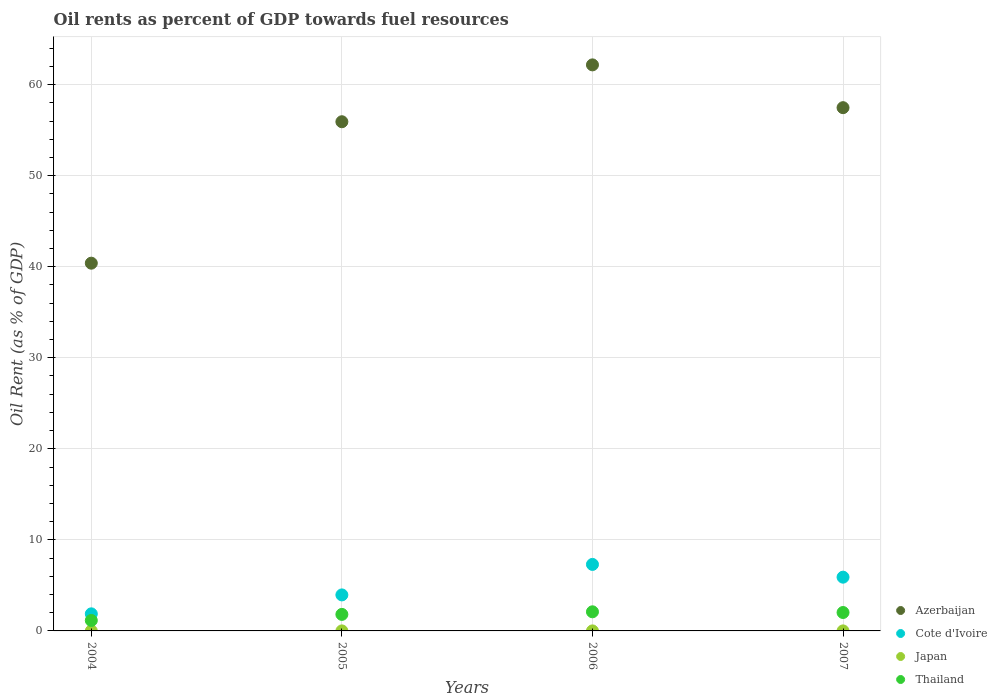How many different coloured dotlines are there?
Give a very brief answer. 4. What is the oil rent in Japan in 2005?
Your answer should be very brief. 0. Across all years, what is the maximum oil rent in Thailand?
Your answer should be compact. 2.1. Across all years, what is the minimum oil rent in Cote d'Ivoire?
Offer a terse response. 1.88. In which year was the oil rent in Thailand minimum?
Give a very brief answer. 2004. What is the total oil rent in Azerbaijan in the graph?
Offer a very short reply. 215.94. What is the difference between the oil rent in Thailand in 2004 and that in 2007?
Offer a very short reply. -0.87. What is the difference between the oil rent in Thailand in 2004 and the oil rent in Japan in 2005?
Offer a terse response. 1.15. What is the average oil rent in Cote d'Ivoire per year?
Provide a succinct answer. 4.76. In the year 2006, what is the difference between the oil rent in Azerbaijan and oil rent in Thailand?
Give a very brief answer. 60.07. What is the ratio of the oil rent in Thailand in 2005 to that in 2007?
Keep it short and to the point. 0.9. Is the oil rent in Azerbaijan in 2006 less than that in 2007?
Offer a very short reply. No. Is the difference between the oil rent in Azerbaijan in 2005 and 2007 greater than the difference between the oil rent in Thailand in 2005 and 2007?
Provide a succinct answer. No. What is the difference between the highest and the second highest oil rent in Japan?
Provide a short and direct response. 0. What is the difference between the highest and the lowest oil rent in Japan?
Your answer should be compact. 0. Is it the case that in every year, the sum of the oil rent in Cote d'Ivoire and oil rent in Thailand  is greater than the oil rent in Japan?
Offer a very short reply. Yes. Does the oil rent in Cote d'Ivoire monotonically increase over the years?
Make the answer very short. No. Is the oil rent in Thailand strictly greater than the oil rent in Japan over the years?
Keep it short and to the point. Yes. Does the graph contain grids?
Your answer should be compact. Yes. How many legend labels are there?
Your answer should be compact. 4. How are the legend labels stacked?
Provide a short and direct response. Vertical. What is the title of the graph?
Offer a very short reply. Oil rents as percent of GDP towards fuel resources. What is the label or title of the X-axis?
Your answer should be very brief. Years. What is the label or title of the Y-axis?
Your response must be concise. Oil Rent (as % of GDP). What is the Oil Rent (as % of GDP) in Azerbaijan in 2004?
Provide a short and direct response. 40.39. What is the Oil Rent (as % of GDP) in Cote d'Ivoire in 2004?
Your response must be concise. 1.88. What is the Oil Rent (as % of GDP) of Japan in 2004?
Ensure brevity in your answer.  0. What is the Oil Rent (as % of GDP) in Thailand in 2004?
Your answer should be compact. 1.15. What is the Oil Rent (as % of GDP) in Azerbaijan in 2005?
Provide a succinct answer. 55.92. What is the Oil Rent (as % of GDP) in Cote d'Ivoire in 2005?
Offer a very short reply. 3.96. What is the Oil Rent (as % of GDP) in Japan in 2005?
Ensure brevity in your answer.  0. What is the Oil Rent (as % of GDP) in Thailand in 2005?
Provide a succinct answer. 1.81. What is the Oil Rent (as % of GDP) of Azerbaijan in 2006?
Provide a short and direct response. 62.17. What is the Oil Rent (as % of GDP) in Cote d'Ivoire in 2006?
Offer a very short reply. 7.3. What is the Oil Rent (as % of GDP) of Japan in 2006?
Offer a terse response. 0. What is the Oil Rent (as % of GDP) in Thailand in 2006?
Make the answer very short. 2.1. What is the Oil Rent (as % of GDP) in Azerbaijan in 2007?
Offer a terse response. 57.47. What is the Oil Rent (as % of GDP) of Cote d'Ivoire in 2007?
Your answer should be compact. 5.9. What is the Oil Rent (as % of GDP) in Japan in 2007?
Offer a very short reply. 0. What is the Oil Rent (as % of GDP) of Thailand in 2007?
Make the answer very short. 2.02. Across all years, what is the maximum Oil Rent (as % of GDP) of Azerbaijan?
Provide a succinct answer. 62.17. Across all years, what is the maximum Oil Rent (as % of GDP) of Cote d'Ivoire?
Your response must be concise. 7.3. Across all years, what is the maximum Oil Rent (as % of GDP) of Japan?
Offer a very short reply. 0. Across all years, what is the maximum Oil Rent (as % of GDP) of Thailand?
Your answer should be very brief. 2.1. Across all years, what is the minimum Oil Rent (as % of GDP) in Azerbaijan?
Provide a short and direct response. 40.39. Across all years, what is the minimum Oil Rent (as % of GDP) of Cote d'Ivoire?
Keep it short and to the point. 1.88. Across all years, what is the minimum Oil Rent (as % of GDP) in Japan?
Your answer should be very brief. 0. Across all years, what is the minimum Oil Rent (as % of GDP) in Thailand?
Ensure brevity in your answer.  1.15. What is the total Oil Rent (as % of GDP) in Azerbaijan in the graph?
Provide a short and direct response. 215.94. What is the total Oil Rent (as % of GDP) in Cote d'Ivoire in the graph?
Make the answer very short. 19.04. What is the total Oil Rent (as % of GDP) of Japan in the graph?
Make the answer very short. 0.01. What is the total Oil Rent (as % of GDP) of Thailand in the graph?
Your answer should be compact. 7.09. What is the difference between the Oil Rent (as % of GDP) of Azerbaijan in 2004 and that in 2005?
Offer a very short reply. -15.53. What is the difference between the Oil Rent (as % of GDP) in Cote d'Ivoire in 2004 and that in 2005?
Ensure brevity in your answer.  -2.08. What is the difference between the Oil Rent (as % of GDP) of Japan in 2004 and that in 2005?
Your response must be concise. -0. What is the difference between the Oil Rent (as % of GDP) in Thailand in 2004 and that in 2005?
Your answer should be very brief. -0.67. What is the difference between the Oil Rent (as % of GDP) of Azerbaijan in 2004 and that in 2006?
Ensure brevity in your answer.  -21.78. What is the difference between the Oil Rent (as % of GDP) in Cote d'Ivoire in 2004 and that in 2006?
Keep it short and to the point. -5.43. What is the difference between the Oil Rent (as % of GDP) in Japan in 2004 and that in 2006?
Provide a succinct answer. -0. What is the difference between the Oil Rent (as % of GDP) of Thailand in 2004 and that in 2006?
Keep it short and to the point. -0.95. What is the difference between the Oil Rent (as % of GDP) of Azerbaijan in 2004 and that in 2007?
Provide a succinct answer. -17.08. What is the difference between the Oil Rent (as % of GDP) of Cote d'Ivoire in 2004 and that in 2007?
Your response must be concise. -4.03. What is the difference between the Oil Rent (as % of GDP) of Japan in 2004 and that in 2007?
Offer a very short reply. -0. What is the difference between the Oil Rent (as % of GDP) of Thailand in 2004 and that in 2007?
Make the answer very short. -0.87. What is the difference between the Oil Rent (as % of GDP) of Azerbaijan in 2005 and that in 2006?
Give a very brief answer. -6.24. What is the difference between the Oil Rent (as % of GDP) of Cote d'Ivoire in 2005 and that in 2006?
Provide a short and direct response. -3.35. What is the difference between the Oil Rent (as % of GDP) of Japan in 2005 and that in 2006?
Provide a short and direct response. -0. What is the difference between the Oil Rent (as % of GDP) in Thailand in 2005 and that in 2006?
Keep it short and to the point. -0.29. What is the difference between the Oil Rent (as % of GDP) of Azerbaijan in 2005 and that in 2007?
Give a very brief answer. -1.54. What is the difference between the Oil Rent (as % of GDP) in Cote d'Ivoire in 2005 and that in 2007?
Offer a very short reply. -1.95. What is the difference between the Oil Rent (as % of GDP) in Japan in 2005 and that in 2007?
Keep it short and to the point. -0. What is the difference between the Oil Rent (as % of GDP) of Thailand in 2005 and that in 2007?
Offer a very short reply. -0.21. What is the difference between the Oil Rent (as % of GDP) of Azerbaijan in 2006 and that in 2007?
Your answer should be very brief. 4.7. What is the difference between the Oil Rent (as % of GDP) in Cote d'Ivoire in 2006 and that in 2007?
Make the answer very short. 1.4. What is the difference between the Oil Rent (as % of GDP) in Japan in 2006 and that in 2007?
Your response must be concise. -0. What is the difference between the Oil Rent (as % of GDP) in Thailand in 2006 and that in 2007?
Provide a succinct answer. 0.08. What is the difference between the Oil Rent (as % of GDP) in Azerbaijan in 2004 and the Oil Rent (as % of GDP) in Cote d'Ivoire in 2005?
Make the answer very short. 36.43. What is the difference between the Oil Rent (as % of GDP) of Azerbaijan in 2004 and the Oil Rent (as % of GDP) of Japan in 2005?
Provide a short and direct response. 40.38. What is the difference between the Oil Rent (as % of GDP) of Azerbaijan in 2004 and the Oil Rent (as % of GDP) of Thailand in 2005?
Provide a short and direct response. 38.57. What is the difference between the Oil Rent (as % of GDP) of Cote d'Ivoire in 2004 and the Oil Rent (as % of GDP) of Japan in 2005?
Offer a terse response. 1.87. What is the difference between the Oil Rent (as % of GDP) in Cote d'Ivoire in 2004 and the Oil Rent (as % of GDP) in Thailand in 2005?
Offer a very short reply. 0.06. What is the difference between the Oil Rent (as % of GDP) in Japan in 2004 and the Oil Rent (as % of GDP) in Thailand in 2005?
Your response must be concise. -1.81. What is the difference between the Oil Rent (as % of GDP) in Azerbaijan in 2004 and the Oil Rent (as % of GDP) in Cote d'Ivoire in 2006?
Provide a short and direct response. 33.08. What is the difference between the Oil Rent (as % of GDP) in Azerbaijan in 2004 and the Oil Rent (as % of GDP) in Japan in 2006?
Your response must be concise. 40.38. What is the difference between the Oil Rent (as % of GDP) of Azerbaijan in 2004 and the Oil Rent (as % of GDP) of Thailand in 2006?
Keep it short and to the point. 38.29. What is the difference between the Oil Rent (as % of GDP) of Cote d'Ivoire in 2004 and the Oil Rent (as % of GDP) of Japan in 2006?
Your response must be concise. 1.87. What is the difference between the Oil Rent (as % of GDP) in Cote d'Ivoire in 2004 and the Oil Rent (as % of GDP) in Thailand in 2006?
Offer a terse response. -0.22. What is the difference between the Oil Rent (as % of GDP) in Japan in 2004 and the Oil Rent (as % of GDP) in Thailand in 2006?
Give a very brief answer. -2.1. What is the difference between the Oil Rent (as % of GDP) in Azerbaijan in 2004 and the Oil Rent (as % of GDP) in Cote d'Ivoire in 2007?
Offer a very short reply. 34.48. What is the difference between the Oil Rent (as % of GDP) in Azerbaijan in 2004 and the Oil Rent (as % of GDP) in Japan in 2007?
Provide a succinct answer. 40.38. What is the difference between the Oil Rent (as % of GDP) of Azerbaijan in 2004 and the Oil Rent (as % of GDP) of Thailand in 2007?
Provide a short and direct response. 38.36. What is the difference between the Oil Rent (as % of GDP) of Cote d'Ivoire in 2004 and the Oil Rent (as % of GDP) of Japan in 2007?
Make the answer very short. 1.87. What is the difference between the Oil Rent (as % of GDP) in Cote d'Ivoire in 2004 and the Oil Rent (as % of GDP) in Thailand in 2007?
Offer a terse response. -0.15. What is the difference between the Oil Rent (as % of GDP) of Japan in 2004 and the Oil Rent (as % of GDP) of Thailand in 2007?
Your answer should be compact. -2.02. What is the difference between the Oil Rent (as % of GDP) in Azerbaijan in 2005 and the Oil Rent (as % of GDP) in Cote d'Ivoire in 2006?
Offer a terse response. 48.62. What is the difference between the Oil Rent (as % of GDP) of Azerbaijan in 2005 and the Oil Rent (as % of GDP) of Japan in 2006?
Offer a very short reply. 55.92. What is the difference between the Oil Rent (as % of GDP) of Azerbaijan in 2005 and the Oil Rent (as % of GDP) of Thailand in 2006?
Provide a succinct answer. 53.82. What is the difference between the Oil Rent (as % of GDP) in Cote d'Ivoire in 2005 and the Oil Rent (as % of GDP) in Japan in 2006?
Keep it short and to the point. 3.95. What is the difference between the Oil Rent (as % of GDP) in Cote d'Ivoire in 2005 and the Oil Rent (as % of GDP) in Thailand in 2006?
Provide a succinct answer. 1.86. What is the difference between the Oil Rent (as % of GDP) in Japan in 2005 and the Oil Rent (as % of GDP) in Thailand in 2006?
Keep it short and to the point. -2.1. What is the difference between the Oil Rent (as % of GDP) of Azerbaijan in 2005 and the Oil Rent (as % of GDP) of Cote d'Ivoire in 2007?
Your answer should be compact. 50.02. What is the difference between the Oil Rent (as % of GDP) in Azerbaijan in 2005 and the Oil Rent (as % of GDP) in Japan in 2007?
Your answer should be very brief. 55.92. What is the difference between the Oil Rent (as % of GDP) of Azerbaijan in 2005 and the Oil Rent (as % of GDP) of Thailand in 2007?
Offer a terse response. 53.9. What is the difference between the Oil Rent (as % of GDP) in Cote d'Ivoire in 2005 and the Oil Rent (as % of GDP) in Japan in 2007?
Your answer should be compact. 3.95. What is the difference between the Oil Rent (as % of GDP) of Cote d'Ivoire in 2005 and the Oil Rent (as % of GDP) of Thailand in 2007?
Keep it short and to the point. 1.93. What is the difference between the Oil Rent (as % of GDP) of Japan in 2005 and the Oil Rent (as % of GDP) of Thailand in 2007?
Your response must be concise. -2.02. What is the difference between the Oil Rent (as % of GDP) in Azerbaijan in 2006 and the Oil Rent (as % of GDP) in Cote d'Ivoire in 2007?
Make the answer very short. 56.26. What is the difference between the Oil Rent (as % of GDP) of Azerbaijan in 2006 and the Oil Rent (as % of GDP) of Japan in 2007?
Provide a short and direct response. 62.16. What is the difference between the Oil Rent (as % of GDP) in Azerbaijan in 2006 and the Oil Rent (as % of GDP) in Thailand in 2007?
Provide a short and direct response. 60.14. What is the difference between the Oil Rent (as % of GDP) of Cote d'Ivoire in 2006 and the Oil Rent (as % of GDP) of Japan in 2007?
Make the answer very short. 7.3. What is the difference between the Oil Rent (as % of GDP) in Cote d'Ivoire in 2006 and the Oil Rent (as % of GDP) in Thailand in 2007?
Give a very brief answer. 5.28. What is the difference between the Oil Rent (as % of GDP) in Japan in 2006 and the Oil Rent (as % of GDP) in Thailand in 2007?
Offer a very short reply. -2.02. What is the average Oil Rent (as % of GDP) in Azerbaijan per year?
Ensure brevity in your answer.  53.98. What is the average Oil Rent (as % of GDP) in Cote d'Ivoire per year?
Your response must be concise. 4.76. What is the average Oil Rent (as % of GDP) in Japan per year?
Provide a short and direct response. 0. What is the average Oil Rent (as % of GDP) in Thailand per year?
Ensure brevity in your answer.  1.77. In the year 2004, what is the difference between the Oil Rent (as % of GDP) of Azerbaijan and Oil Rent (as % of GDP) of Cote d'Ivoire?
Your response must be concise. 38.51. In the year 2004, what is the difference between the Oil Rent (as % of GDP) in Azerbaijan and Oil Rent (as % of GDP) in Japan?
Ensure brevity in your answer.  40.38. In the year 2004, what is the difference between the Oil Rent (as % of GDP) in Azerbaijan and Oil Rent (as % of GDP) in Thailand?
Your answer should be compact. 39.24. In the year 2004, what is the difference between the Oil Rent (as % of GDP) in Cote d'Ivoire and Oil Rent (as % of GDP) in Japan?
Your answer should be very brief. 1.87. In the year 2004, what is the difference between the Oil Rent (as % of GDP) in Cote d'Ivoire and Oil Rent (as % of GDP) in Thailand?
Provide a succinct answer. 0.73. In the year 2004, what is the difference between the Oil Rent (as % of GDP) in Japan and Oil Rent (as % of GDP) in Thailand?
Your response must be concise. -1.15. In the year 2005, what is the difference between the Oil Rent (as % of GDP) of Azerbaijan and Oil Rent (as % of GDP) of Cote d'Ivoire?
Your answer should be very brief. 51.97. In the year 2005, what is the difference between the Oil Rent (as % of GDP) of Azerbaijan and Oil Rent (as % of GDP) of Japan?
Your answer should be compact. 55.92. In the year 2005, what is the difference between the Oil Rent (as % of GDP) in Azerbaijan and Oil Rent (as % of GDP) in Thailand?
Provide a succinct answer. 54.11. In the year 2005, what is the difference between the Oil Rent (as % of GDP) in Cote d'Ivoire and Oil Rent (as % of GDP) in Japan?
Offer a terse response. 3.95. In the year 2005, what is the difference between the Oil Rent (as % of GDP) of Cote d'Ivoire and Oil Rent (as % of GDP) of Thailand?
Keep it short and to the point. 2.14. In the year 2005, what is the difference between the Oil Rent (as % of GDP) in Japan and Oil Rent (as % of GDP) in Thailand?
Offer a terse response. -1.81. In the year 2006, what is the difference between the Oil Rent (as % of GDP) of Azerbaijan and Oil Rent (as % of GDP) of Cote d'Ivoire?
Make the answer very short. 54.86. In the year 2006, what is the difference between the Oil Rent (as % of GDP) of Azerbaijan and Oil Rent (as % of GDP) of Japan?
Your answer should be very brief. 62.16. In the year 2006, what is the difference between the Oil Rent (as % of GDP) in Azerbaijan and Oil Rent (as % of GDP) in Thailand?
Provide a short and direct response. 60.07. In the year 2006, what is the difference between the Oil Rent (as % of GDP) in Cote d'Ivoire and Oil Rent (as % of GDP) in Japan?
Offer a very short reply. 7.3. In the year 2006, what is the difference between the Oil Rent (as % of GDP) in Cote d'Ivoire and Oil Rent (as % of GDP) in Thailand?
Make the answer very short. 5.2. In the year 2006, what is the difference between the Oil Rent (as % of GDP) in Japan and Oil Rent (as % of GDP) in Thailand?
Provide a short and direct response. -2.1. In the year 2007, what is the difference between the Oil Rent (as % of GDP) in Azerbaijan and Oil Rent (as % of GDP) in Cote d'Ivoire?
Your response must be concise. 51.56. In the year 2007, what is the difference between the Oil Rent (as % of GDP) of Azerbaijan and Oil Rent (as % of GDP) of Japan?
Keep it short and to the point. 57.46. In the year 2007, what is the difference between the Oil Rent (as % of GDP) of Azerbaijan and Oil Rent (as % of GDP) of Thailand?
Make the answer very short. 55.44. In the year 2007, what is the difference between the Oil Rent (as % of GDP) of Cote d'Ivoire and Oil Rent (as % of GDP) of Japan?
Offer a very short reply. 5.9. In the year 2007, what is the difference between the Oil Rent (as % of GDP) of Cote d'Ivoire and Oil Rent (as % of GDP) of Thailand?
Your answer should be very brief. 3.88. In the year 2007, what is the difference between the Oil Rent (as % of GDP) of Japan and Oil Rent (as % of GDP) of Thailand?
Give a very brief answer. -2.02. What is the ratio of the Oil Rent (as % of GDP) of Azerbaijan in 2004 to that in 2005?
Provide a succinct answer. 0.72. What is the ratio of the Oil Rent (as % of GDP) in Cote d'Ivoire in 2004 to that in 2005?
Your answer should be compact. 0.47. What is the ratio of the Oil Rent (as % of GDP) in Japan in 2004 to that in 2005?
Give a very brief answer. 0.62. What is the ratio of the Oil Rent (as % of GDP) in Thailand in 2004 to that in 2005?
Your response must be concise. 0.63. What is the ratio of the Oil Rent (as % of GDP) in Azerbaijan in 2004 to that in 2006?
Offer a terse response. 0.65. What is the ratio of the Oil Rent (as % of GDP) in Cote d'Ivoire in 2004 to that in 2006?
Ensure brevity in your answer.  0.26. What is the ratio of the Oil Rent (as % of GDP) in Japan in 2004 to that in 2006?
Ensure brevity in your answer.  0.56. What is the ratio of the Oil Rent (as % of GDP) of Thailand in 2004 to that in 2006?
Your response must be concise. 0.55. What is the ratio of the Oil Rent (as % of GDP) in Azerbaijan in 2004 to that in 2007?
Provide a succinct answer. 0.7. What is the ratio of the Oil Rent (as % of GDP) in Cote d'Ivoire in 2004 to that in 2007?
Ensure brevity in your answer.  0.32. What is the ratio of the Oil Rent (as % of GDP) of Japan in 2004 to that in 2007?
Make the answer very short. 0.49. What is the ratio of the Oil Rent (as % of GDP) of Thailand in 2004 to that in 2007?
Give a very brief answer. 0.57. What is the ratio of the Oil Rent (as % of GDP) in Azerbaijan in 2005 to that in 2006?
Provide a short and direct response. 0.9. What is the ratio of the Oil Rent (as % of GDP) of Cote d'Ivoire in 2005 to that in 2006?
Offer a very short reply. 0.54. What is the ratio of the Oil Rent (as % of GDP) of Japan in 2005 to that in 2006?
Offer a very short reply. 0.89. What is the ratio of the Oil Rent (as % of GDP) of Thailand in 2005 to that in 2006?
Keep it short and to the point. 0.86. What is the ratio of the Oil Rent (as % of GDP) in Azerbaijan in 2005 to that in 2007?
Provide a succinct answer. 0.97. What is the ratio of the Oil Rent (as % of GDP) in Cote d'Ivoire in 2005 to that in 2007?
Your response must be concise. 0.67. What is the ratio of the Oil Rent (as % of GDP) in Japan in 2005 to that in 2007?
Offer a very short reply. 0.79. What is the ratio of the Oil Rent (as % of GDP) of Thailand in 2005 to that in 2007?
Provide a succinct answer. 0.9. What is the ratio of the Oil Rent (as % of GDP) in Azerbaijan in 2006 to that in 2007?
Provide a succinct answer. 1.08. What is the ratio of the Oil Rent (as % of GDP) in Cote d'Ivoire in 2006 to that in 2007?
Make the answer very short. 1.24. What is the ratio of the Oil Rent (as % of GDP) of Japan in 2006 to that in 2007?
Your response must be concise. 0.89. What is the ratio of the Oil Rent (as % of GDP) in Thailand in 2006 to that in 2007?
Ensure brevity in your answer.  1.04. What is the difference between the highest and the second highest Oil Rent (as % of GDP) in Azerbaijan?
Keep it short and to the point. 4.7. What is the difference between the highest and the second highest Oil Rent (as % of GDP) of Cote d'Ivoire?
Keep it short and to the point. 1.4. What is the difference between the highest and the second highest Oil Rent (as % of GDP) of Japan?
Offer a very short reply. 0. What is the difference between the highest and the second highest Oil Rent (as % of GDP) in Thailand?
Provide a succinct answer. 0.08. What is the difference between the highest and the lowest Oil Rent (as % of GDP) in Azerbaijan?
Provide a short and direct response. 21.78. What is the difference between the highest and the lowest Oil Rent (as % of GDP) in Cote d'Ivoire?
Your answer should be compact. 5.43. What is the difference between the highest and the lowest Oil Rent (as % of GDP) in Japan?
Offer a terse response. 0. What is the difference between the highest and the lowest Oil Rent (as % of GDP) of Thailand?
Your response must be concise. 0.95. 